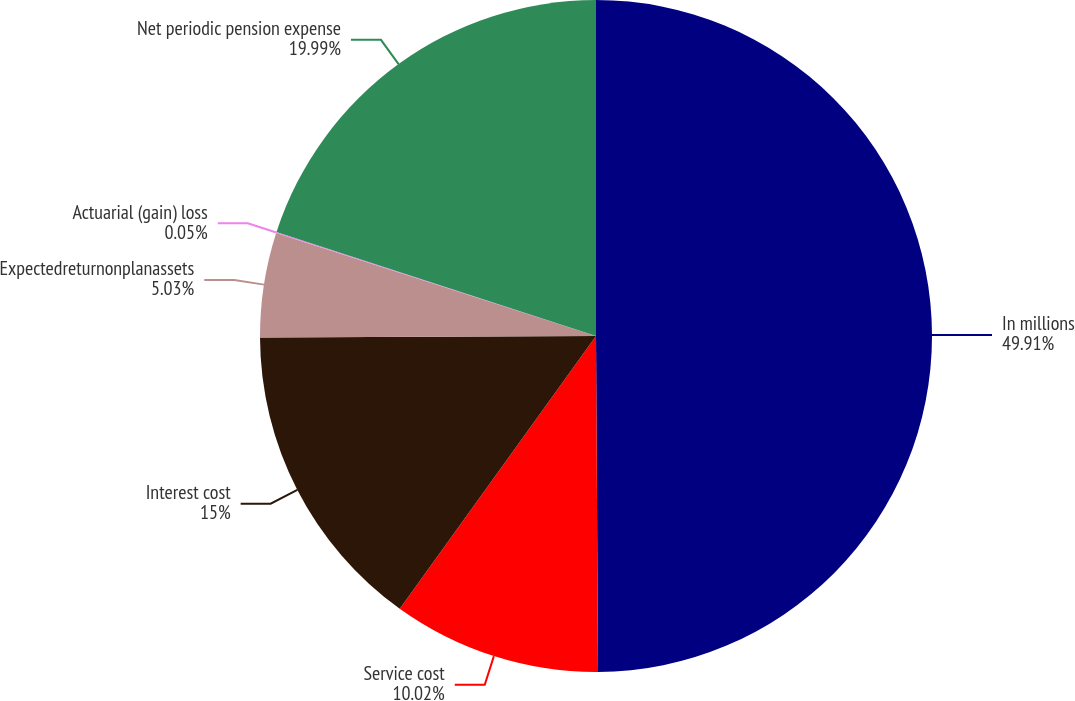<chart> <loc_0><loc_0><loc_500><loc_500><pie_chart><fcel>In millions<fcel>Service cost<fcel>Interest cost<fcel>Expectedreturnonplanassets<fcel>Actuarial (gain) loss<fcel>Net periodic pension expense<nl><fcel>49.9%<fcel>10.02%<fcel>15.0%<fcel>5.03%<fcel>0.05%<fcel>19.99%<nl></chart> 